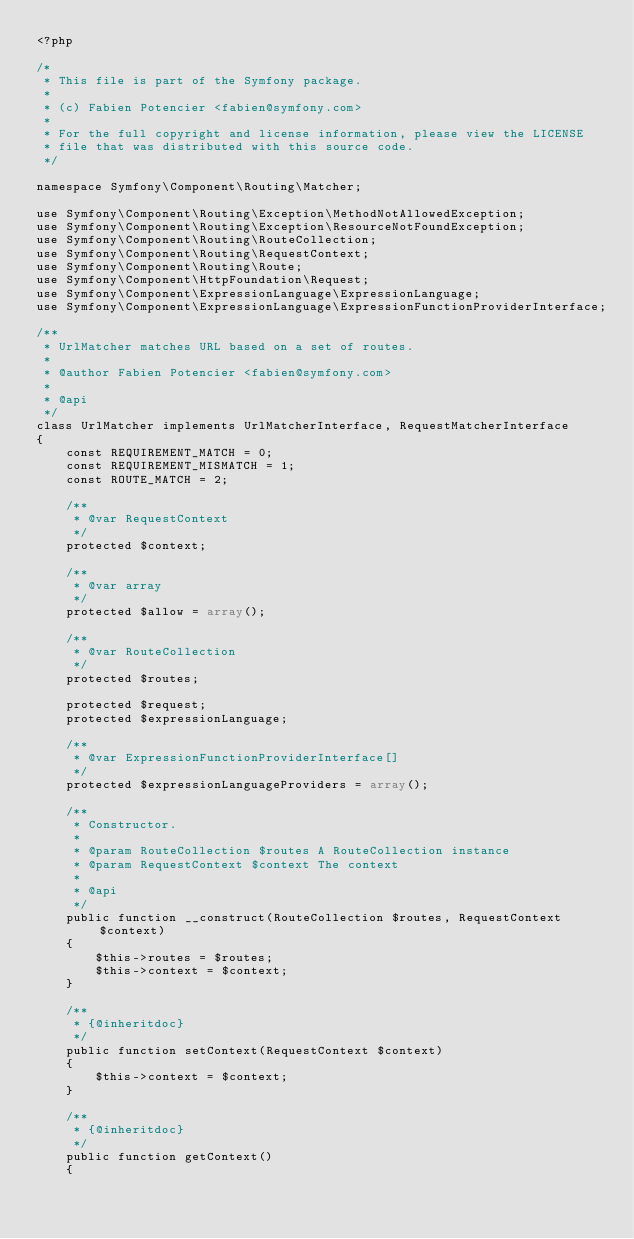Convert code to text. <code><loc_0><loc_0><loc_500><loc_500><_PHP_><?php

/*
 * This file is part of the Symfony package.
 *
 * (c) Fabien Potencier <fabien@symfony.com>
 *
 * For the full copyright and license information, please view the LICENSE
 * file that was distributed with this source code.
 */

namespace Symfony\Component\Routing\Matcher;

use Symfony\Component\Routing\Exception\MethodNotAllowedException;
use Symfony\Component\Routing\Exception\ResourceNotFoundException;
use Symfony\Component\Routing\RouteCollection;
use Symfony\Component\Routing\RequestContext;
use Symfony\Component\Routing\Route;
use Symfony\Component\HttpFoundation\Request;
use Symfony\Component\ExpressionLanguage\ExpressionLanguage;
use Symfony\Component\ExpressionLanguage\ExpressionFunctionProviderInterface;

/**
 * UrlMatcher matches URL based on a set of routes.
 *
 * @author Fabien Potencier <fabien@symfony.com>
 *
 * @api
 */
class UrlMatcher implements UrlMatcherInterface, RequestMatcherInterface
{
    const REQUIREMENT_MATCH = 0;
    const REQUIREMENT_MISMATCH = 1;
    const ROUTE_MATCH = 2;

    /**
     * @var RequestContext
     */
    protected $context;

    /**
     * @var array
     */
    protected $allow = array();

    /**
     * @var RouteCollection
     */
    protected $routes;

    protected $request;
    protected $expressionLanguage;

    /**
     * @var ExpressionFunctionProviderInterface[]
     */
    protected $expressionLanguageProviders = array();

    /**
     * Constructor.
     *
     * @param RouteCollection $routes A RouteCollection instance
     * @param RequestContext $context The context
     *
     * @api
     */
    public function __construct(RouteCollection $routes, RequestContext $context)
    {
        $this->routes = $routes;
        $this->context = $context;
    }

    /**
     * {@inheritdoc}
     */
    public function setContext(RequestContext $context)
    {
        $this->context = $context;
    }

    /**
     * {@inheritdoc}
     */
    public function getContext()
    {</code> 